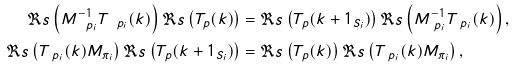Convert formula to latex. <formula><loc_0><loc_0><loc_500><loc_500>\Re s \left ( M _ { \ p _ { i } } ^ { - 1 } T _ { \ p _ { i } } ( k ) \right ) \Re s \left ( T _ { p } ( k ) \right ) & = \Re s \left ( T _ { p } ( k + 1 _ { S _ { i } } ) \right ) \Re s \left ( M _ { \ p _ { i } } ^ { - 1 } T _ { \ p _ { i } } ( k ) \right ) , \\ \Re s \left ( T _ { \ p _ { i } } ( k ) M _ { \pi _ { i } } \right ) \Re s \left ( T _ { p } ( k + 1 _ { S _ { i } } ) \right ) & = \Re s \left ( T _ { p } ( k ) \right ) \Re s \left ( T _ { \ p _ { i } } ( k ) M _ { \pi _ { i } } \right ) ,</formula> 